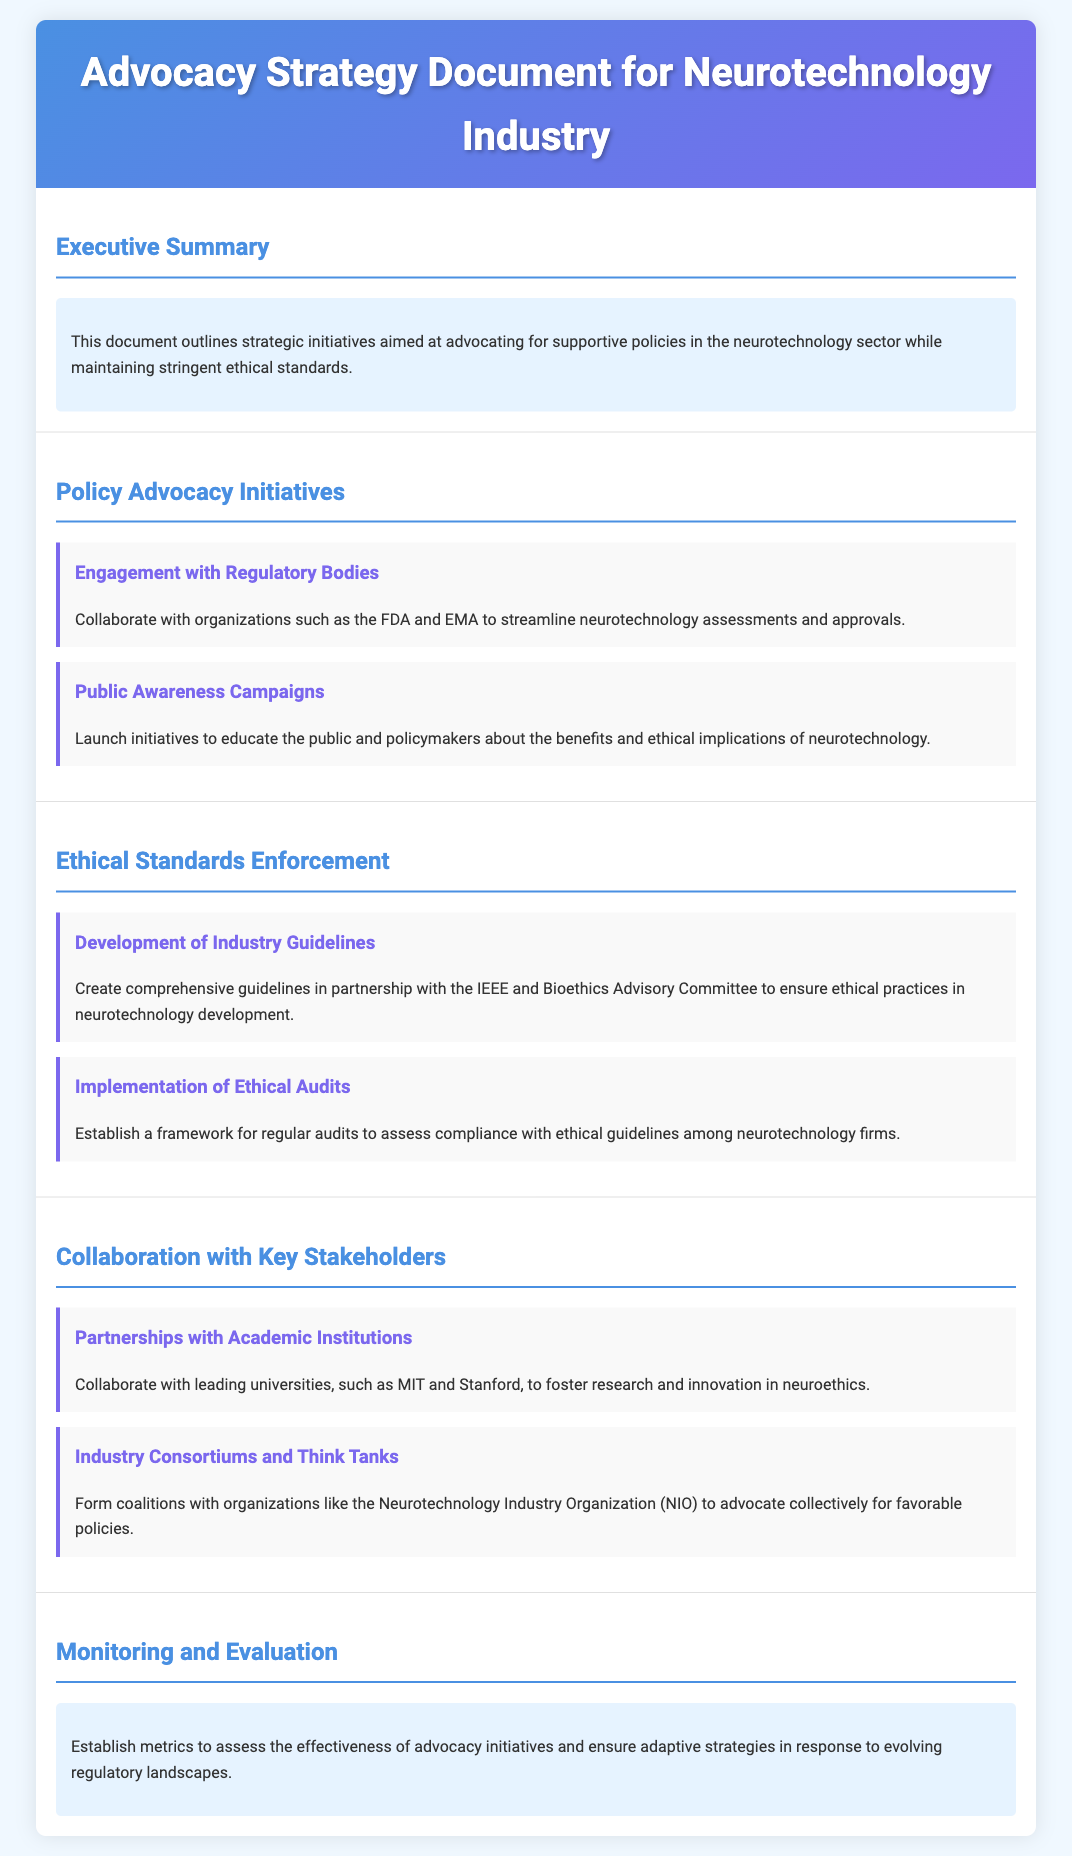What is the title of the document? The title is stated in the header section of the document.
Answer: Advocacy Strategy Document for Neurotechnology Industry What organization collaborates with the FDA and EMA? The text mentions collaboration with regulatory bodies as part of the initiatives.
Answer: Organizations What campaign is planned to raise public awareness? The document outlines initiatives for educating the public, which is a specific action plan mentioned.
Answer: Public Awareness Campaigns Which two institutions are mentioned for collaboration on neuroethics research? The document lists academic collaborations in one of the sections.
Answer: MIT and Stanford What is established for regular audits? The item outlines the creation of a specific framework as part of ethical standards enforcement.
Answer: Ethical Audits What is the goal of advocacy initiatives mentioned in the document? The document highlights a goal of advocating for supportive policies in the neurotechnology sector.
Answer: Supportive policies How many sections are there in the document? The number of sections can be counted from the organizational structure outlined in the document.
Answer: Five Who are the members of the industry consortium mentioned? The document lists specific organizations that form coalitions.
Answer: Neurotechnology Industry Organization What is the purpose of developing industry guidelines? The guidelines are aimed at ensuring ethical practices in neurotechnology.
Answer: Ethical practices 